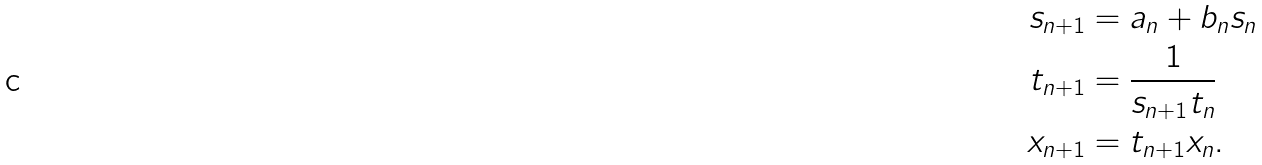Convert formula to latex. <formula><loc_0><loc_0><loc_500><loc_500>s _ { n + 1 } & = a _ { n } + b _ { n } s _ { n } \\ t _ { n + 1 } & = \frac { 1 } { s _ { n + 1 } t _ { n } } \\ x _ { n + 1 } & = t _ { n + 1 } x _ { n } .</formula> 